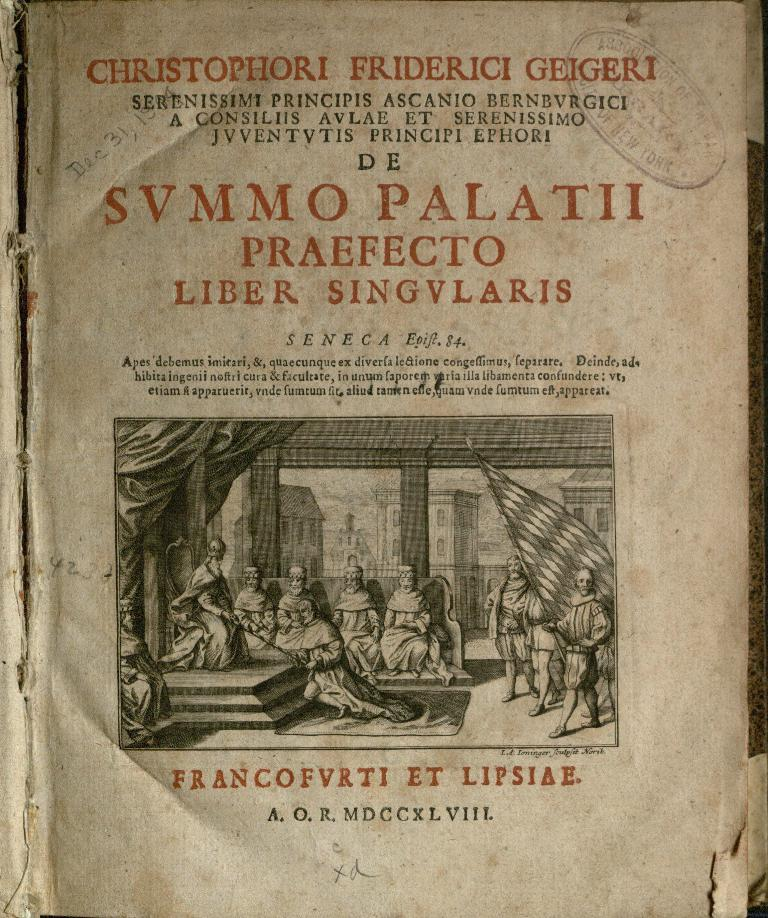<image>
Present a compact description of the photo's key features. Book open on a page that says "LIBER SINGVLARIS" near the middle. 